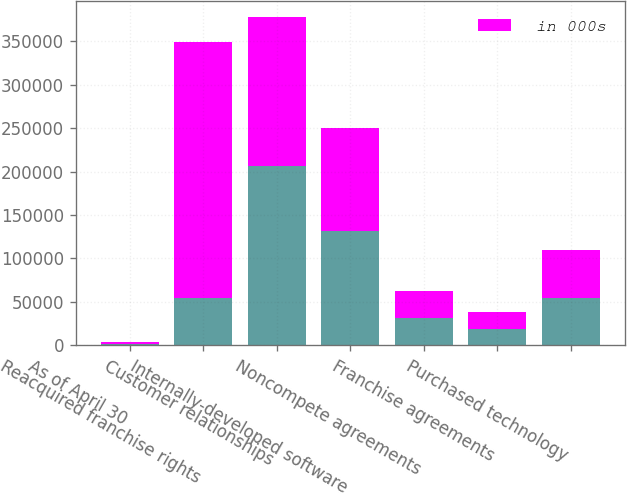Convert chart to OTSL. <chart><loc_0><loc_0><loc_500><loc_500><stacked_bar_chart><ecel><fcel>As of April 30<fcel>Reacquired franchise rights<fcel>Customer relationships<fcel>Internally-developed software<fcel>Noncompete agreements<fcel>Franchise agreements<fcel>Purchased technology<nl><fcel>nan<fcel>2016<fcel>54700<fcel>206607<fcel>131161<fcel>31499<fcel>19201<fcel>54700<nl><fcel>in 000s<fcel>2015<fcel>294647<fcel>170851<fcel>118865<fcel>30630<fcel>19201<fcel>54700<nl></chart> 